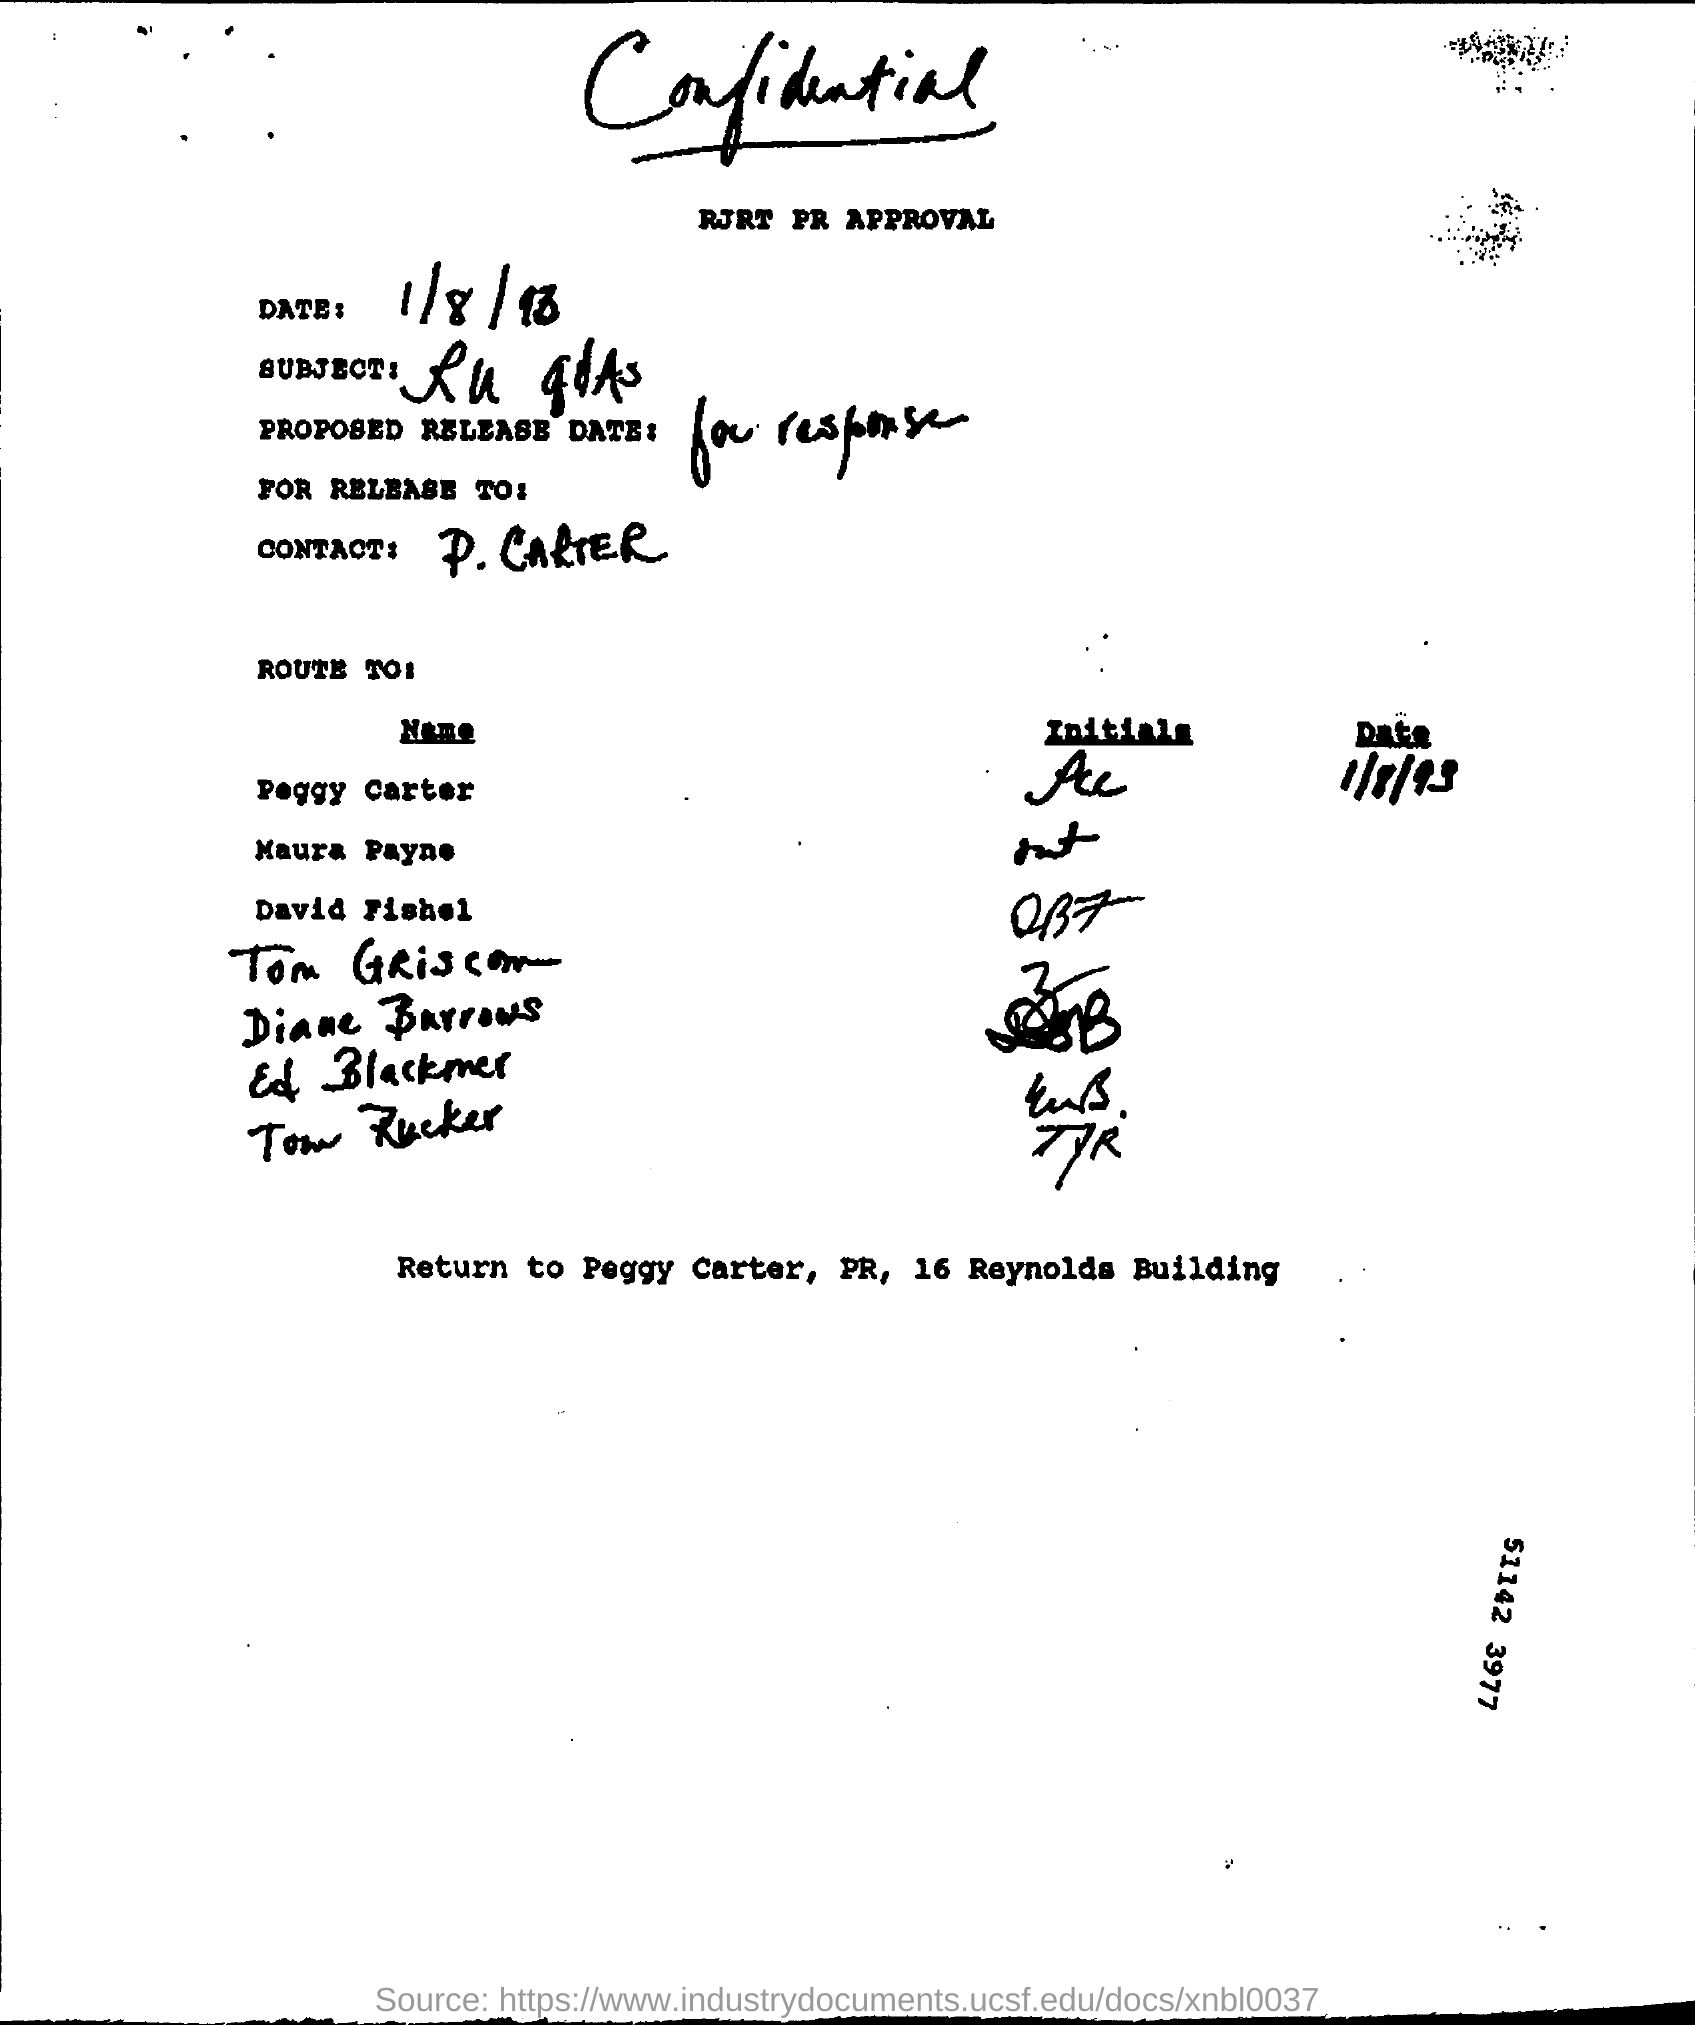Outline some significant characteristics in this image. The contact person's name mentioned in the letter is P. Carter. The date mentioned in this letter is 1/8/93. 